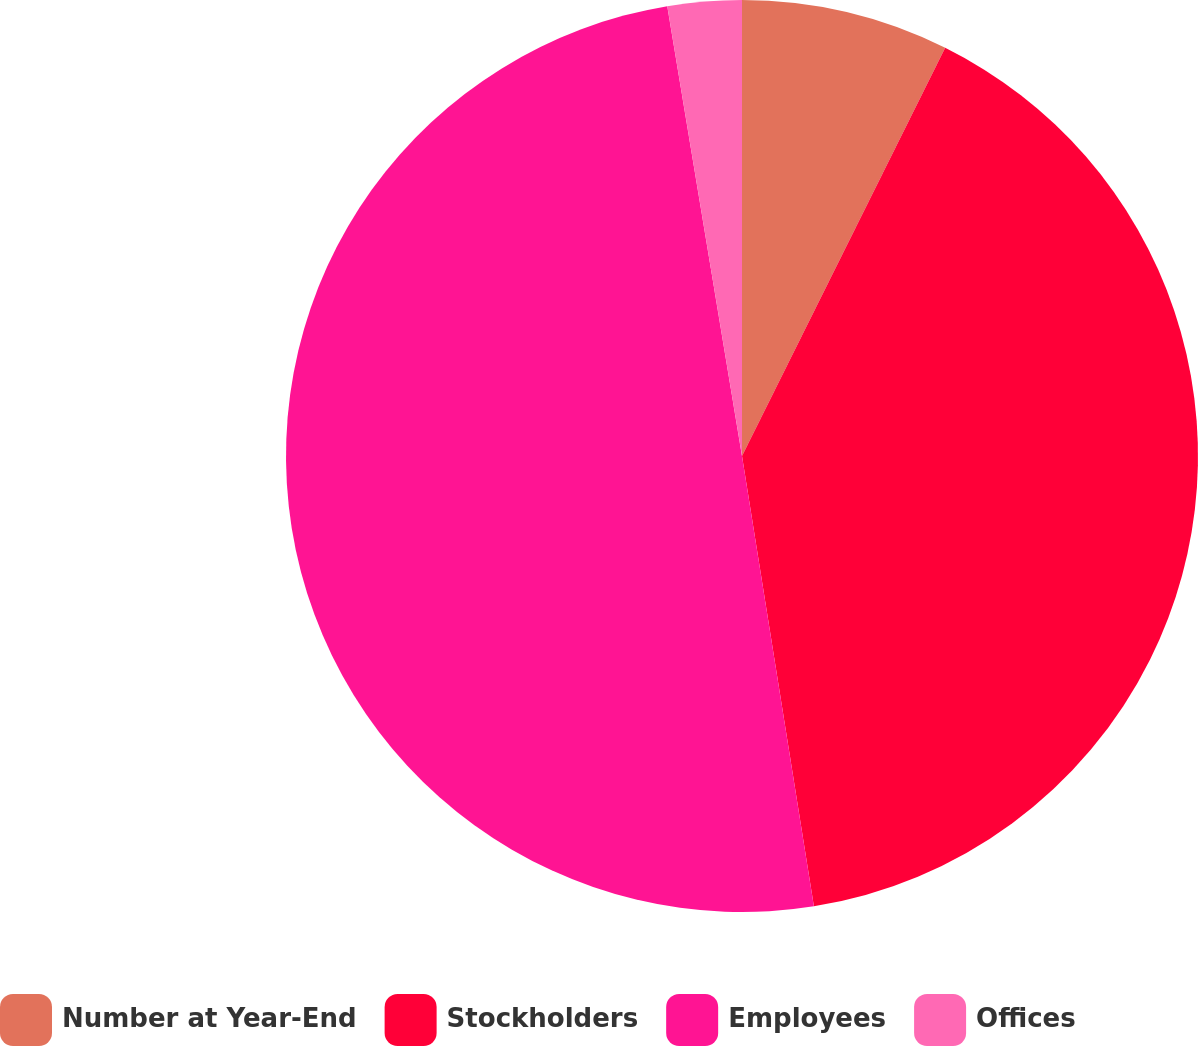Convert chart to OTSL. <chart><loc_0><loc_0><loc_500><loc_500><pie_chart><fcel>Number at Year-End<fcel>Stockholders<fcel>Employees<fcel>Offices<nl><fcel>7.35%<fcel>40.13%<fcel>49.9%<fcel>2.62%<nl></chart> 